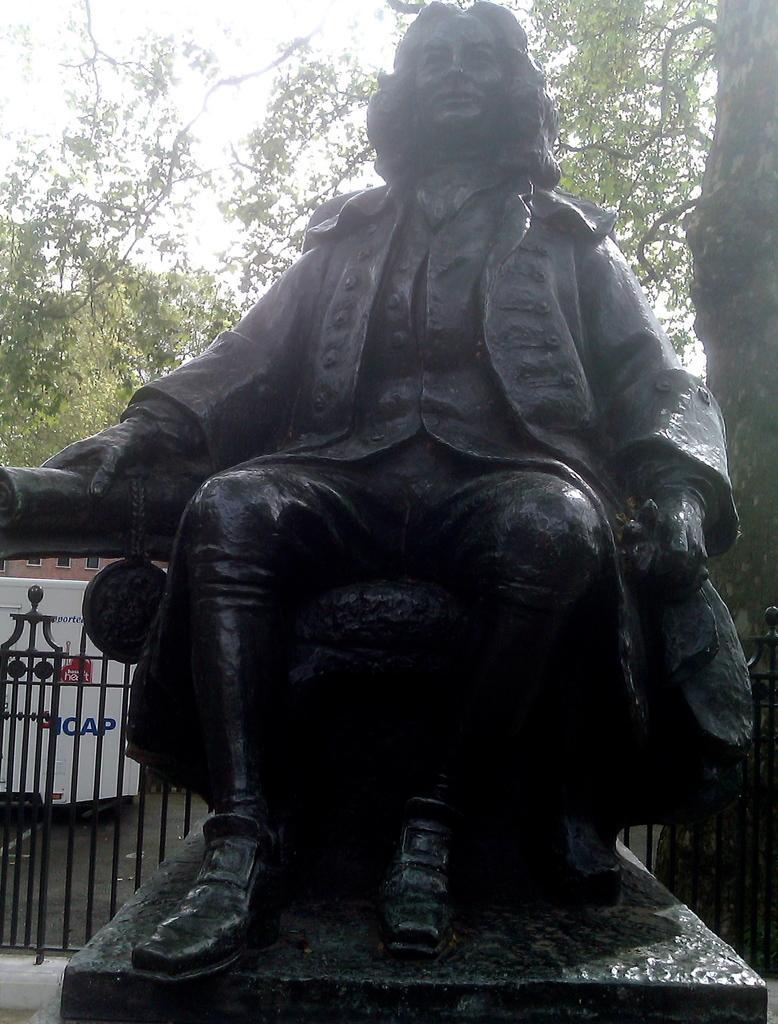In one or two sentences, can you explain what this image depicts? In this picture there is a statue of a person sitting and there is a fence behind him and there are trees in the background. 